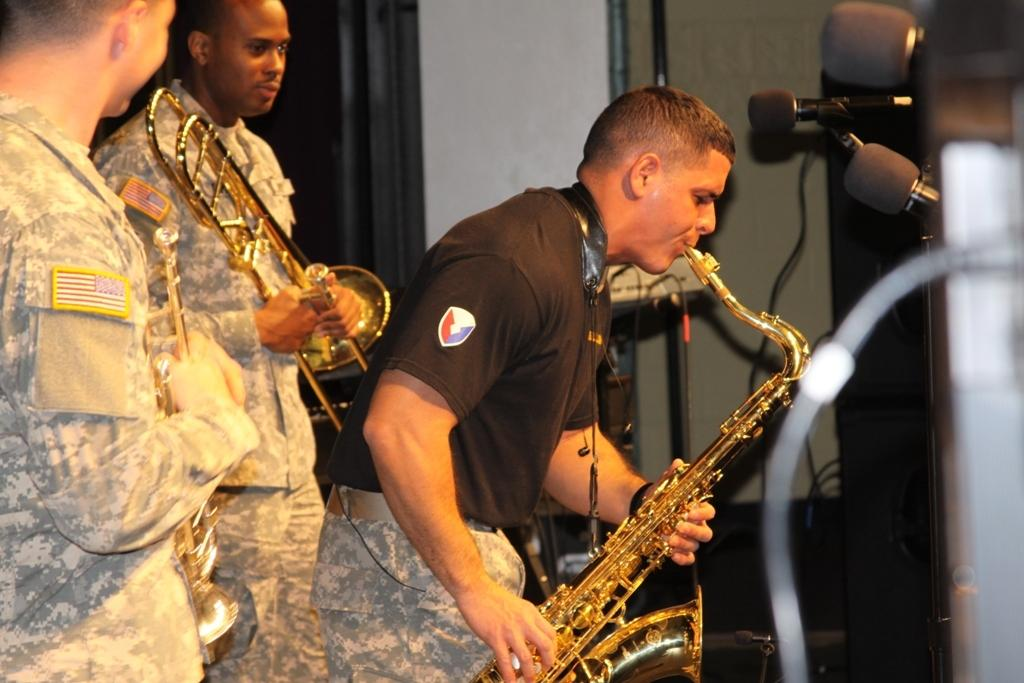How many people are in the image? There are three men in the image. What are two of the men wearing? Two of the men are wearing uniforms. What are the men holding in the image? All three men are holding musical instruments. What else can be seen in the image besides the men and their instruments? There are mics visible in the image. What type of trade is being conducted by the men in the image? There is no indication of a trade being conducted in the image; the men are holding musical instruments and appear to be part of a performance or band. --- Facts: 1. There is a car in the image. 2. The car is parked on the street. 3. There are trees in the background of the image. 4. The sky is visible in the image. Absurd Topics: parrot, sand, dance Conversation: What is the main subject of the image? The main subject of the image is a car. Where is the car located in the image? The car is parked on the street. What can be seen in the background of the image? There are trees in the background of the image. What else is visible in the image besides the car and trees? The sky is visible in the image. Reasoning: Let's think step by step in order to produce the conversation. We start by identifying the main subject of the image, which is the car. Then, we describe the location of the car, which is parked on the street. Next, we mention the background of the image, which includes trees. Finally, we include additional details about the image, such as the visible sky. Absurd Question/Answer: Can you tell me how many parrots are sitting on the car in the image? There are no parrots present in the image; it features a car parked on the street with trees and the sky visible in the background. 